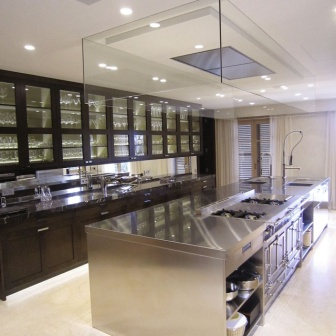Analyze the image in a comprehensive and detailed manner.
 The image showcases a modern kitchen, bathed in natural light from a large window adorned with white blinds. The heart of the kitchen is a large stainless steel island, centrally positioned and equipped with a gas range and a sink that features a tall faucet. 

The island is surrounded by dark wood cabinets, their glass doors revealing an array of dishes and glassware within. These cabinets lend a warm contrast to the cool steel of the island. Above the island, a glass pendant light hangs from the ceiling, ready to illuminate the space as needed.

The floor beneath is composed of light-colored tiles, reflecting the light from the window and the pendant light, and enhancing the overall brightness of the kitchen. The precise layout and the strategic placement of the elements create a harmonious balance in the kitchen, making it a welcoming and functional space. 